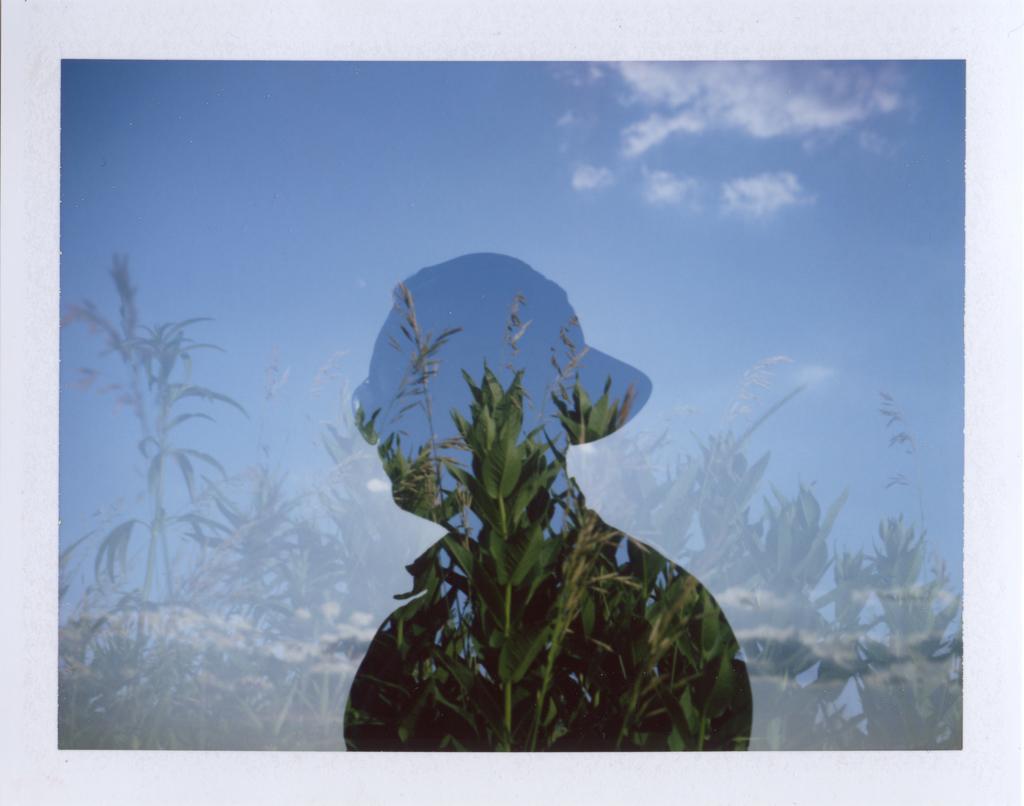Could you give a brief overview of what you see in this image? In the image we can see there is a shadow of a person and there are plants. There is a clear sky. 